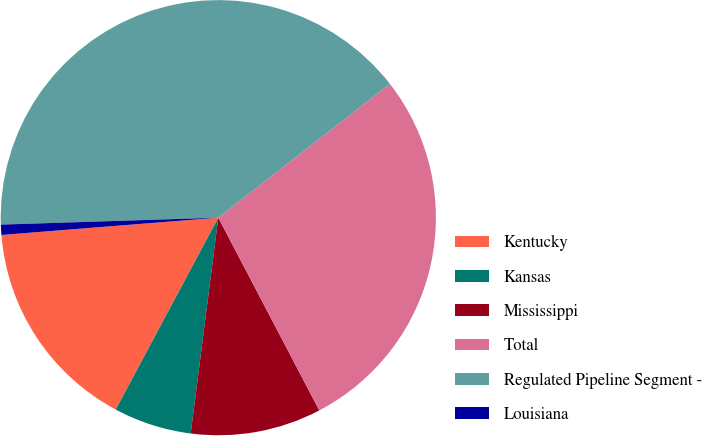Convert chart to OTSL. <chart><loc_0><loc_0><loc_500><loc_500><pie_chart><fcel>Kentucky<fcel>Kansas<fcel>Mississippi<fcel>Total<fcel>Regulated Pipeline Segment -<fcel>Louisiana<nl><fcel>15.92%<fcel>5.79%<fcel>9.71%<fcel>27.86%<fcel>39.97%<fcel>0.76%<nl></chart> 